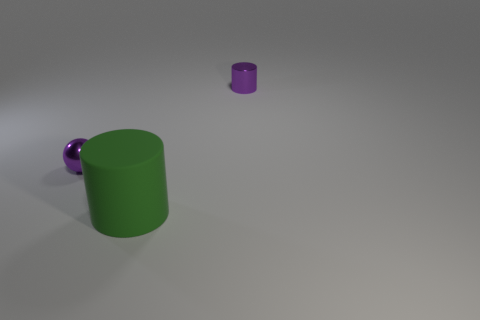Are there fewer tiny objects than purple metal balls?
Provide a succinct answer. No. Are the tiny sphere and the tiny cylinder made of the same material?
Ensure brevity in your answer.  Yes. How many other things are there of the same color as the rubber object?
Ensure brevity in your answer.  0. Are there more large red rubber cylinders than large green matte objects?
Provide a succinct answer. No. Does the sphere have the same size as the object behind the tiny metallic sphere?
Your answer should be compact. Yes. What color is the small metal cylinder that is behind the tiny ball?
Your response must be concise. Purple. What number of red objects are large rubber objects or tiny shiny cylinders?
Your answer should be compact. 0. What is the color of the ball?
Provide a succinct answer. Purple. Is there anything else that is the same material as the large cylinder?
Keep it short and to the point. No. Are there fewer green objects in front of the small sphere than big green cylinders right of the metal cylinder?
Offer a terse response. No. 